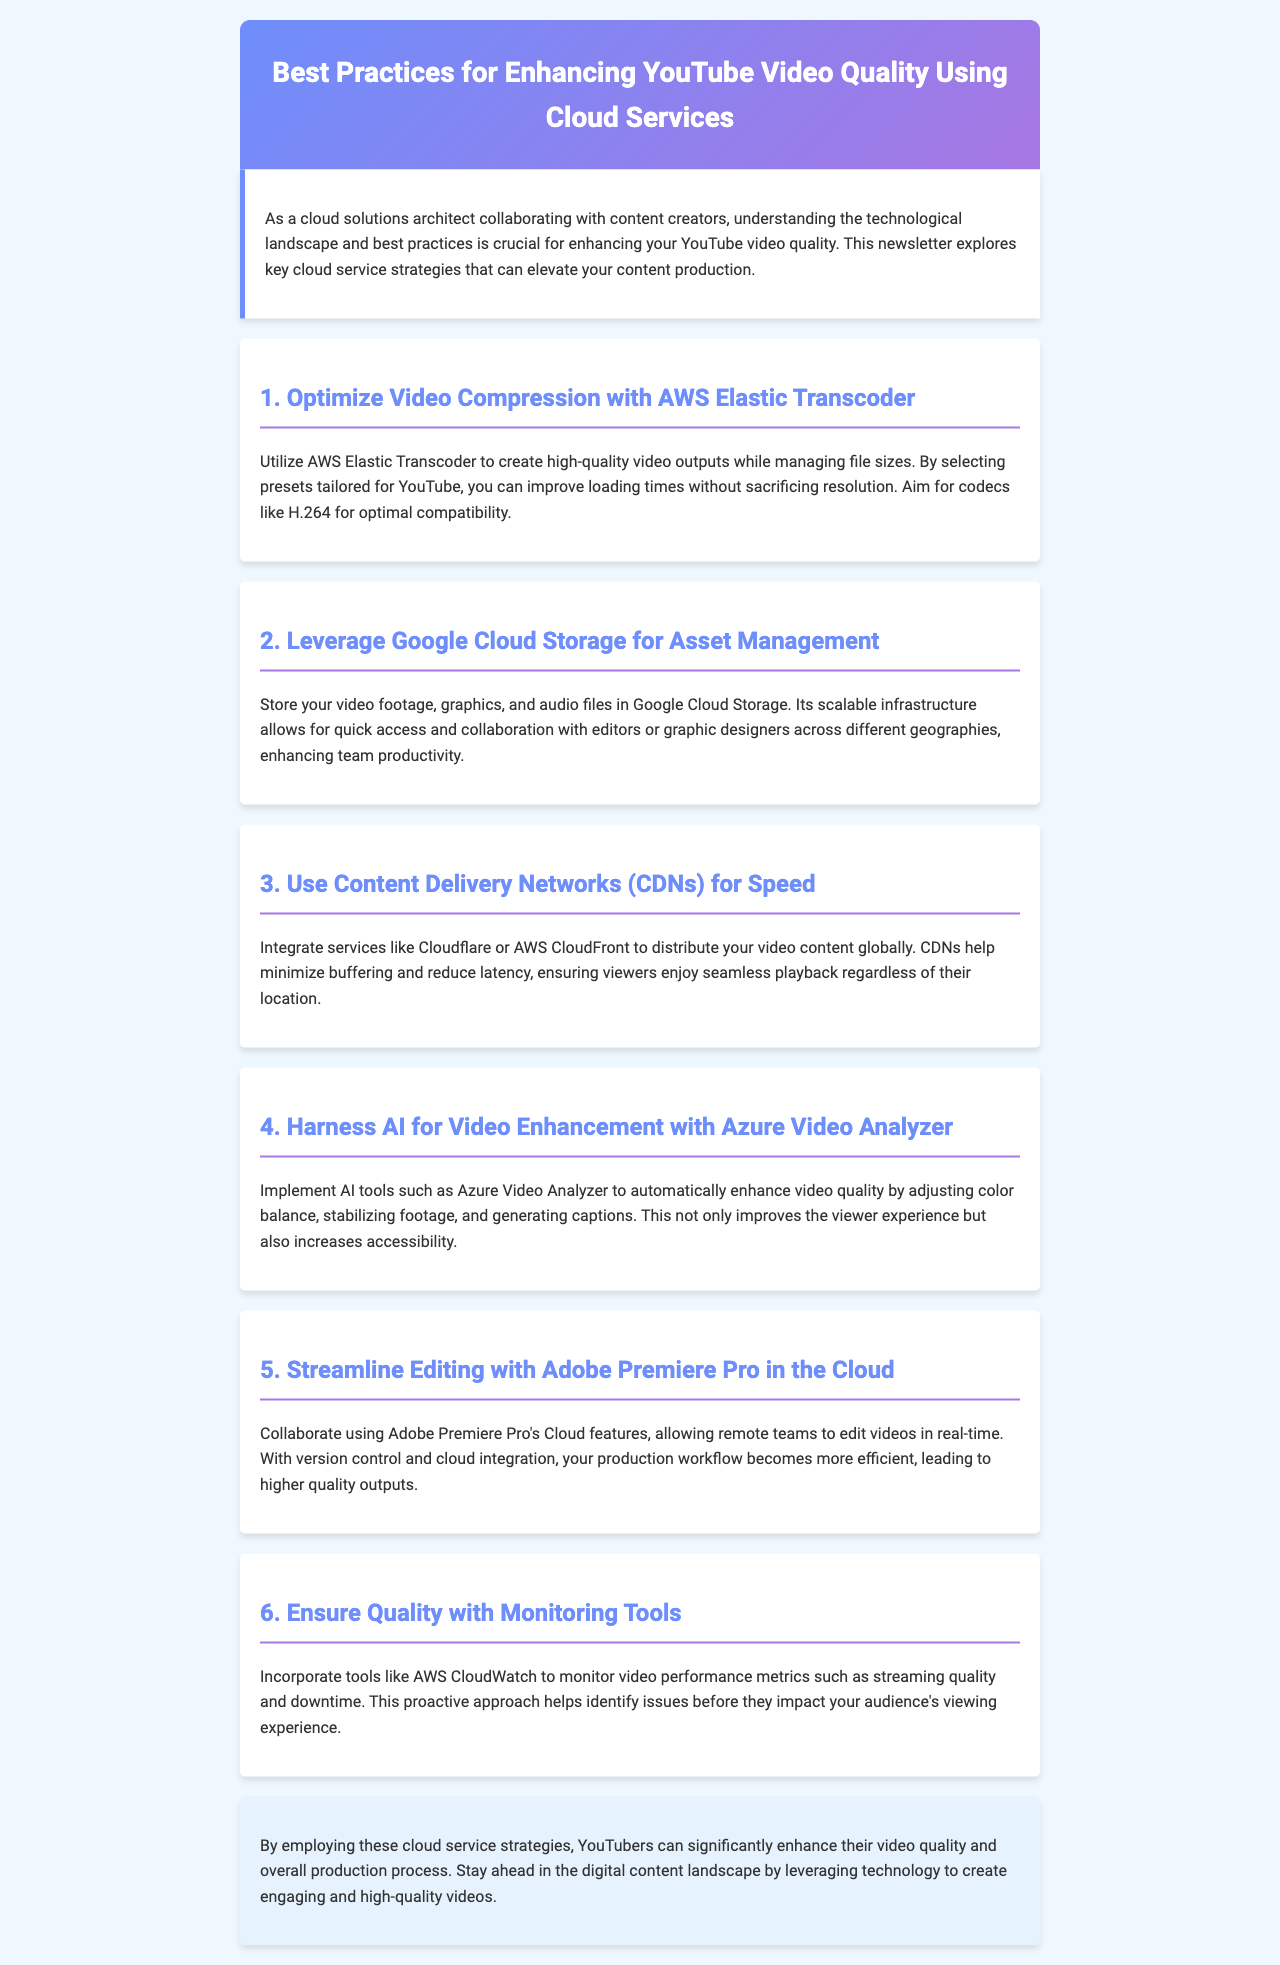What is the title of the newsletter? The title of the newsletter is provided at the top section of the document, highlighting the content focus.
Answer: Best Practices for Enhancing YouTube Video Quality Using Cloud Services How many main sections are in the newsletter? The newsletter has multiple sections, each dedicated to a specific best practice, and the exact count can be found in the content.
Answer: 6 Which cloud service is suggested for video compression? The document specifies AWS Elastic Transcoder as the cloud service for optimizing video compression.
Answer: AWS Elastic Transcoder What is a recommended codec for video outputs? The text recommends using specific codecs for better compatibility, which can be found in the compression section.
Answer: H.264 Which AI tool is mentioned for video enhancement? The newsletter mentions a specific AI tool that can assist in enhancing video quality automatically, found in the relevant section.
Answer: Azure Video Analyzer What should be monitored to ensure video quality? The document suggests incorporating specific monitoring tools to oversee various video performance metrics.
Answer: AWS CloudWatch What type of content service is integrated for speed? The newsletter recommends using a type of service that specializes in content distribution to improve viewing speed, detailed in the content section.
Answer: CDN Which video editing software is discussed for collaborative work? The document references a popular video editing software known for its cloud features that facilitate teamwork on video projects.
Answer: Adobe Premiere Pro 